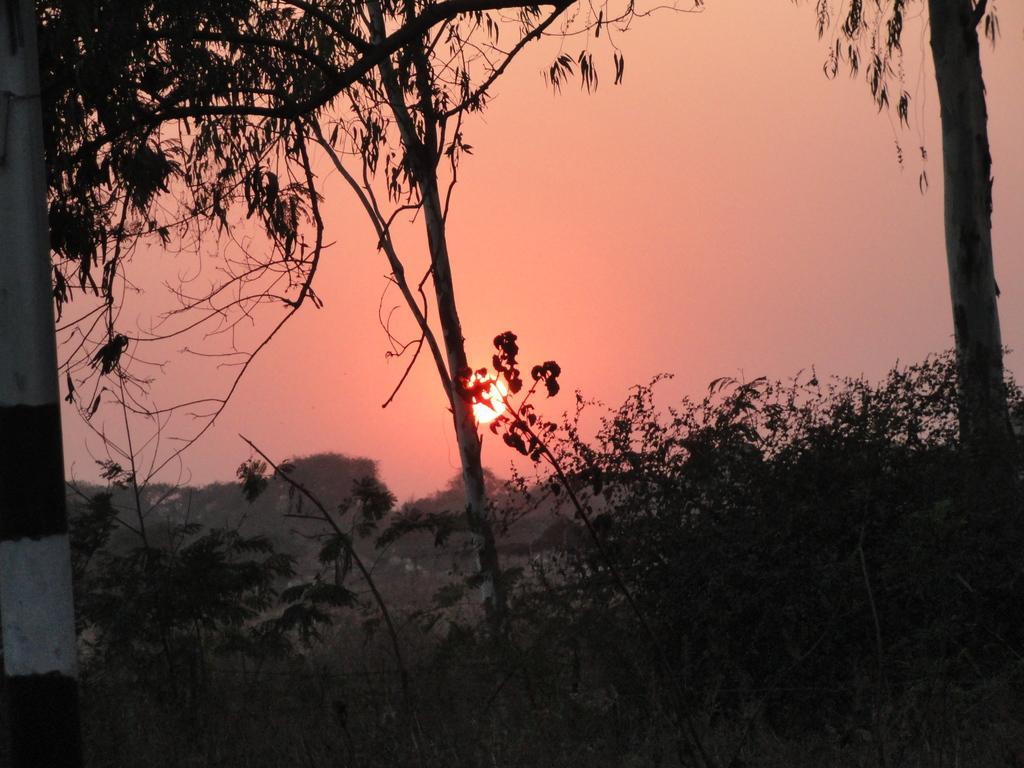Describe this image in one or two sentences. In this picture, it looks like a pole and behind the pole there are plants, trees and the sun in the sky. 